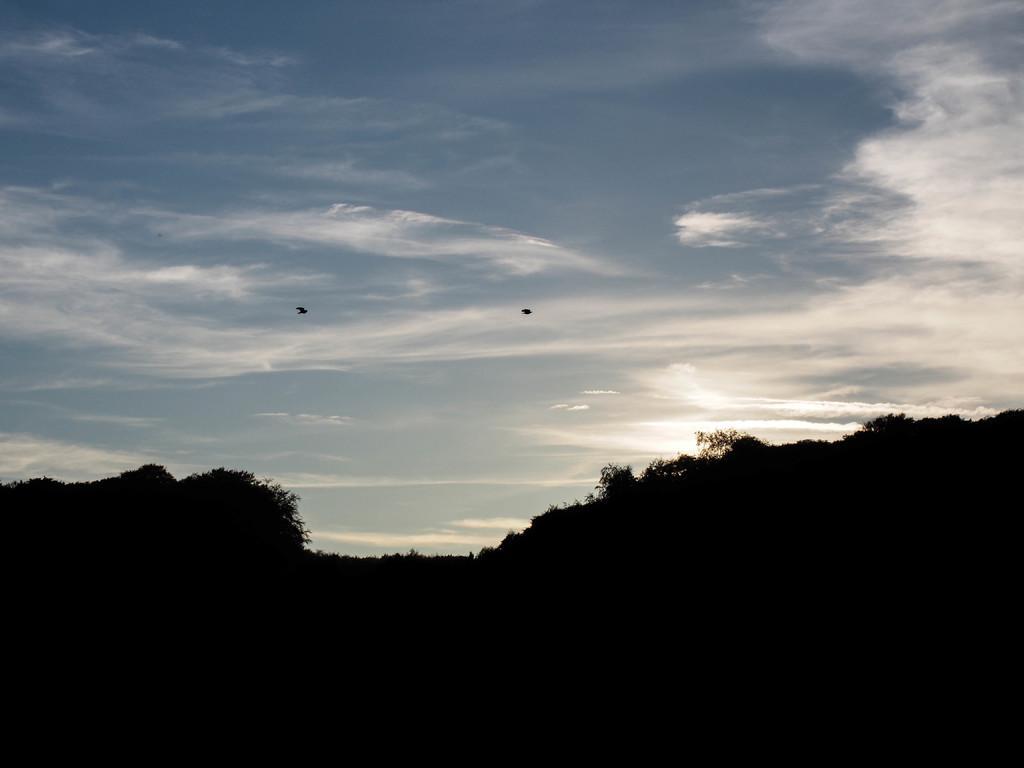How would you summarize this image in a sentence or two? In the image we can see hills, trees and a cloudy pale blue sky. We can even see there are bird flying in the sky. 